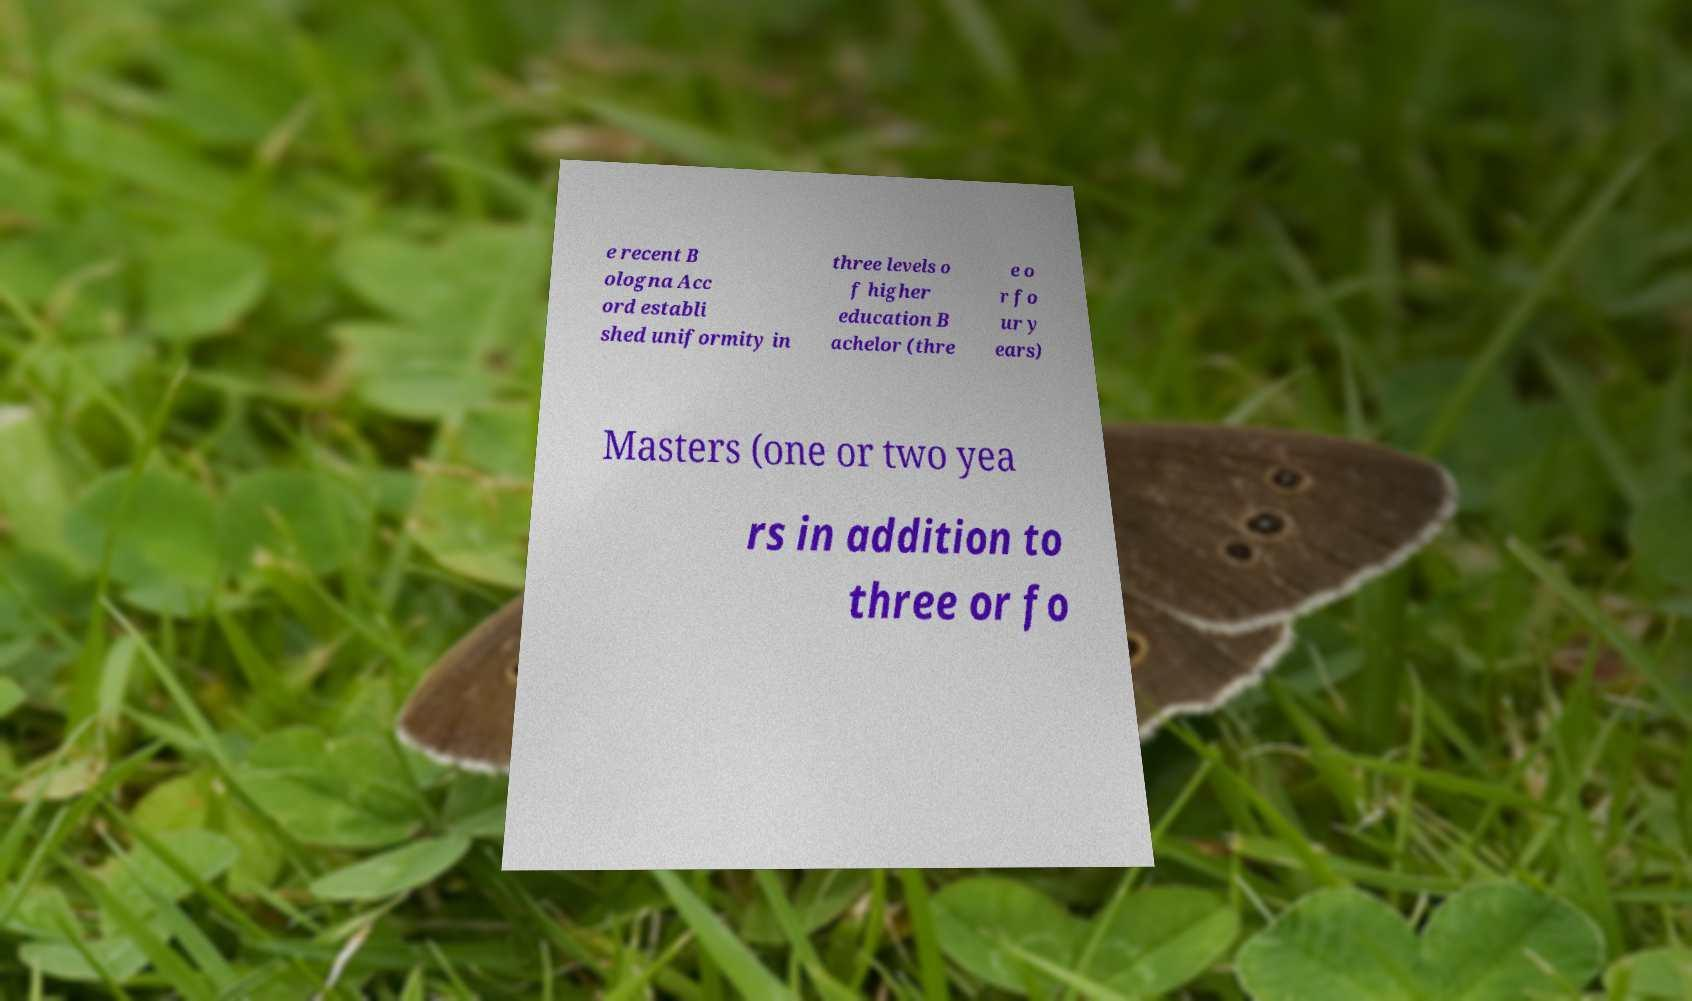Can you accurately transcribe the text from the provided image for me? e recent B ologna Acc ord establi shed uniformity in three levels o f higher education B achelor (thre e o r fo ur y ears) Masters (one or two yea rs in addition to three or fo 